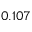Convert formula to latex. <formula><loc_0><loc_0><loc_500><loc_500>0 . 1 0 7</formula> 